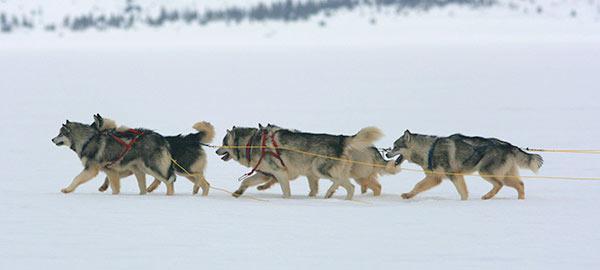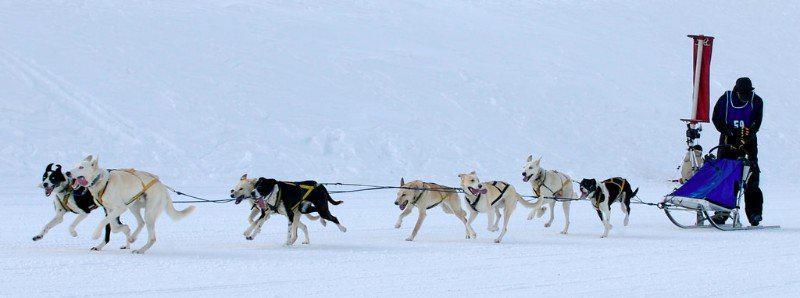The first image is the image on the left, the second image is the image on the right. Examine the images to the left and right. Is the description "There is only one human visible in the pair of images." accurate? Answer yes or no. Yes. The first image is the image on the left, the second image is the image on the right. Given the left and right images, does the statement "The teams of dogs in the left and right images are headed in the same direction." hold true? Answer yes or no. Yes. 